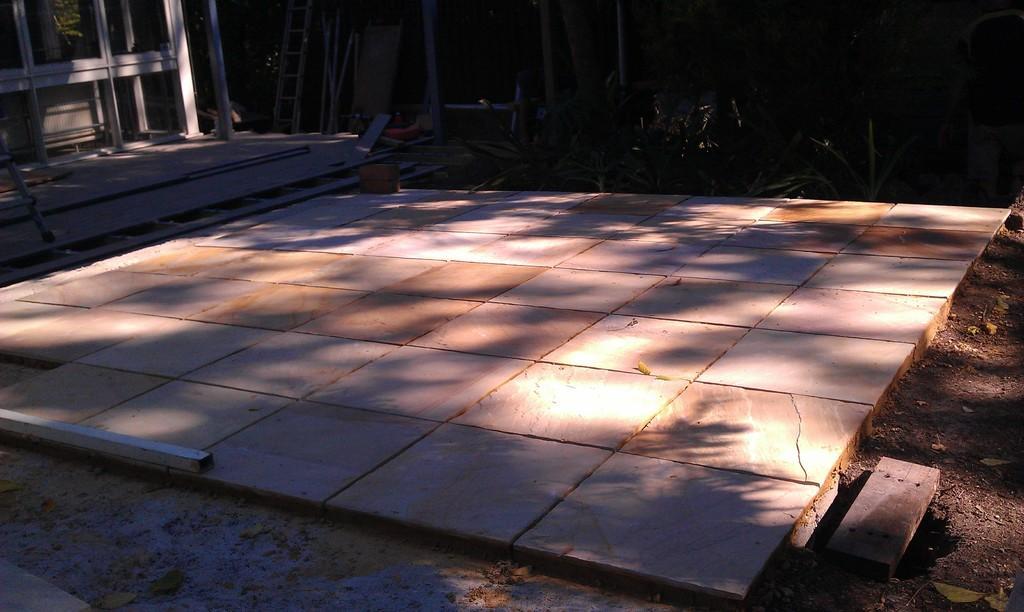Could you give a brief overview of what you see in this image? There is a floor with tiles. In the back there are few plants. Also there is a ladder. And there are rods and wooden pieces. 